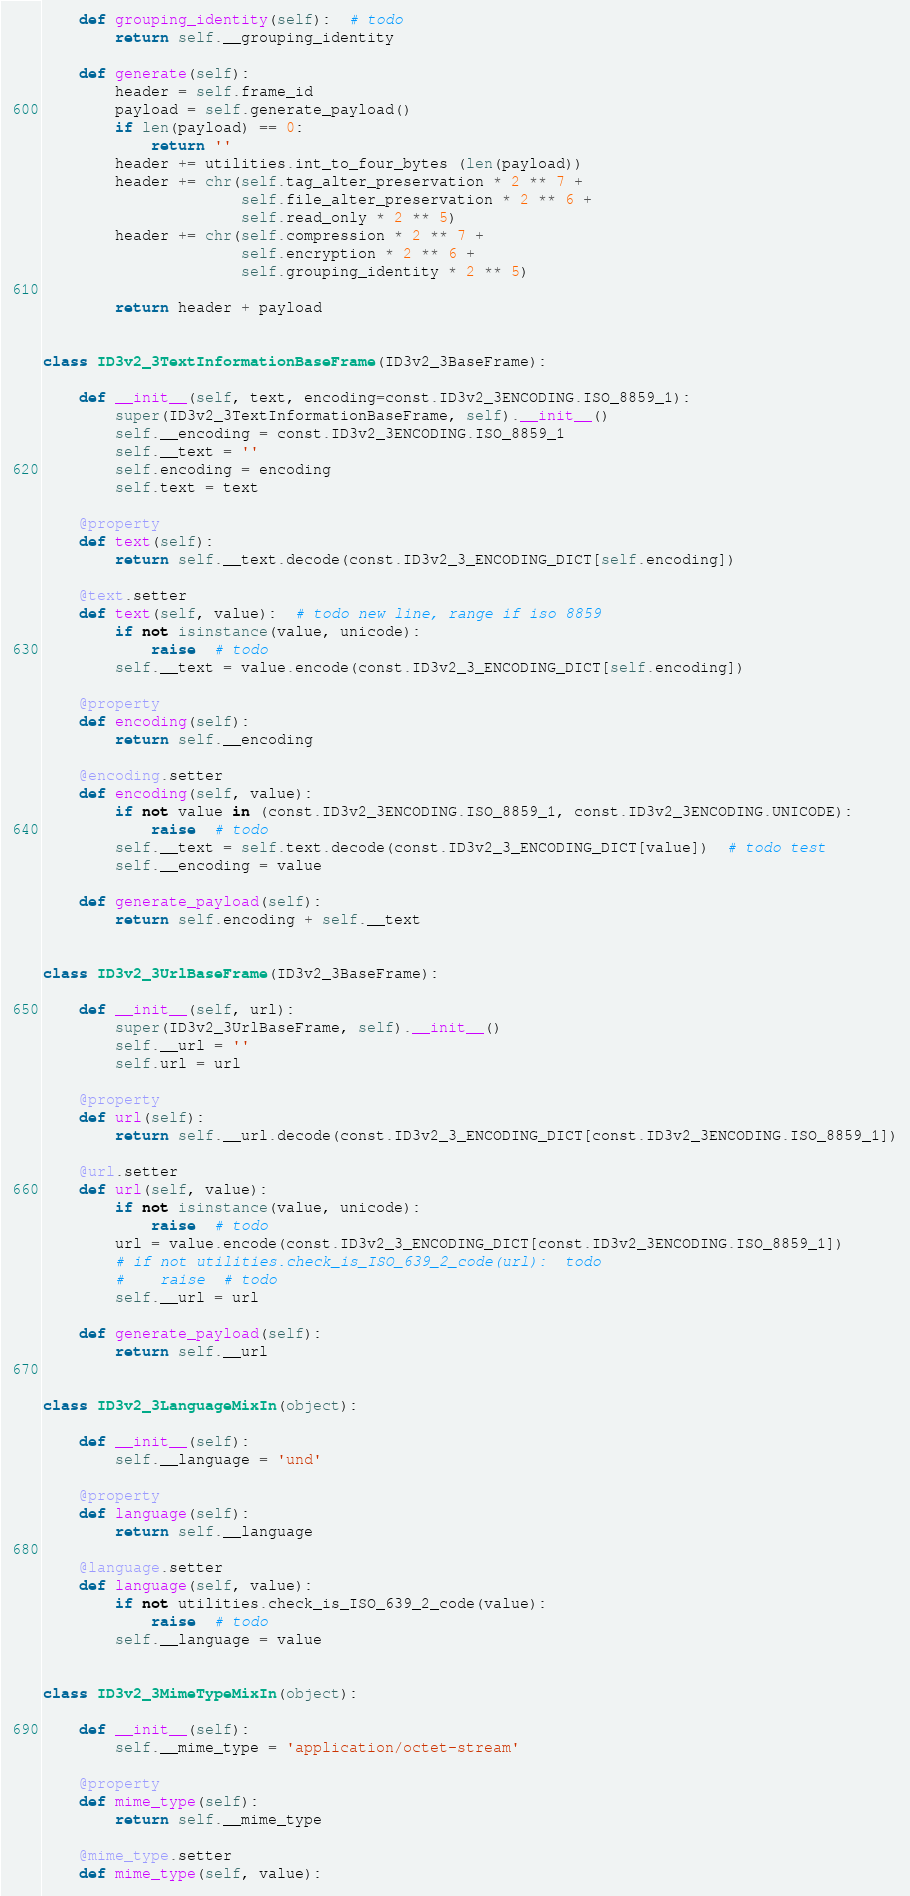Convert code to text. <code><loc_0><loc_0><loc_500><loc_500><_Python_>    def grouping_identity(self):  # todo
        return self.__grouping_identity

    def generate(self):
        header = self.frame_id
        payload = self.generate_payload()
        if len(payload) == 0:
            return ''
        header += utilities.int_to_four_bytes (len(payload))
        header += chr(self.tag_alter_preservation * 2 ** 7 +
                      self.file_alter_preservation * 2 ** 6 +
                      self.read_only * 2 ** 5)
        header += chr(self.compression * 2 ** 7 +
                      self.encryption * 2 ** 6 +
                      self.grouping_identity * 2 ** 5)

        return header + payload


class ID3v2_3TextInformationBaseFrame(ID3v2_3BaseFrame):

    def __init__(self, text, encoding=const.ID3v2_3ENCODING.ISO_8859_1):
        super(ID3v2_3TextInformationBaseFrame, self).__init__()
        self.__encoding = const.ID3v2_3ENCODING.ISO_8859_1
        self.__text = ''
        self.encoding = encoding
        self.text = text

    @property
    def text(self):
        return self.__text.decode(const.ID3v2_3_ENCODING_DICT[self.encoding])

    @text.setter
    def text(self, value):  # todo new line, range if iso 8859
        if not isinstance(value, unicode):
            raise  # todo
        self.__text = value.encode(const.ID3v2_3_ENCODING_DICT[self.encoding])

    @property
    def encoding(self):
        return self.__encoding

    @encoding.setter
    def encoding(self, value):
        if not value in (const.ID3v2_3ENCODING.ISO_8859_1, const.ID3v2_3ENCODING.UNICODE):
            raise  # todo
        self.__text = self.text.decode(const.ID3v2_3_ENCODING_DICT[value])  # todo test
        self.__encoding = value

    def generate_payload(self):
        return self.encoding + self.__text


class ID3v2_3UrlBaseFrame(ID3v2_3BaseFrame):

    def __init__(self, url):
        super(ID3v2_3UrlBaseFrame, self).__init__()
        self.__url = ''
        self.url = url

    @property
    def url(self):
        return self.__url.decode(const.ID3v2_3_ENCODING_DICT[const.ID3v2_3ENCODING.ISO_8859_1])

    @url.setter
    def url(self, value):
        if not isinstance(value, unicode):
            raise  # todo
        url = value.encode(const.ID3v2_3_ENCODING_DICT[const.ID3v2_3ENCODING.ISO_8859_1])
        # if not utilities.check_is_ISO_639_2_code(url):  todo
        #    raise  # todo
        self.__url = url

    def generate_payload(self):
        return self.__url


class ID3v2_3LanguageMixIn(object):

    def __init__(self):
        self.__language = 'und'

    @property
    def language(self):
        return self.__language

    @language.setter
    def language(self, value):
        if not utilities.check_is_ISO_639_2_code(value):
            raise  # todo
        self.__language = value


class ID3v2_3MimeTypeMixIn(object):

    def __init__(self):
        self.__mime_type = 'application/octet-stream'

    @property
    def mime_type(self):
        return self.__mime_type

    @mime_type.setter
    def mime_type(self, value):</code> 